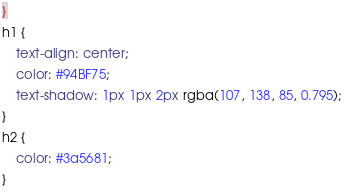Convert code to text. <code><loc_0><loc_0><loc_500><loc_500><_CSS_>}
h1 {
    text-align: center;
    color: #94BF75;
    text-shadow: 1px 1px 2px rgba(107, 138, 85, 0.795);
}
h2 {
    color: #3a5681;
}</code> 